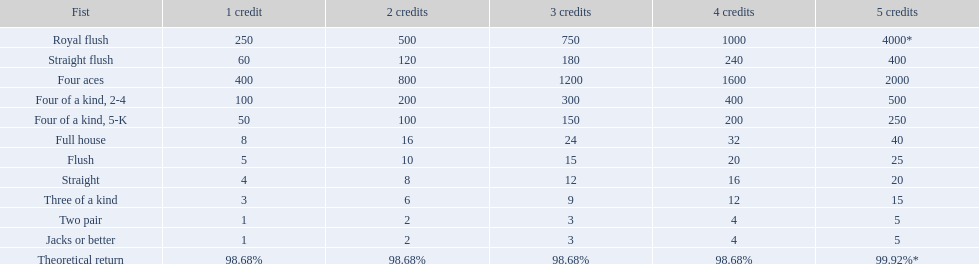What are the hands? Royal flush, Straight flush, Four aces, Four of a kind, 2-4, Four of a kind, 5-K, Full house, Flush, Straight, Three of a kind, Two pair, Jacks or better. Which hand is on the top? Royal flush. 